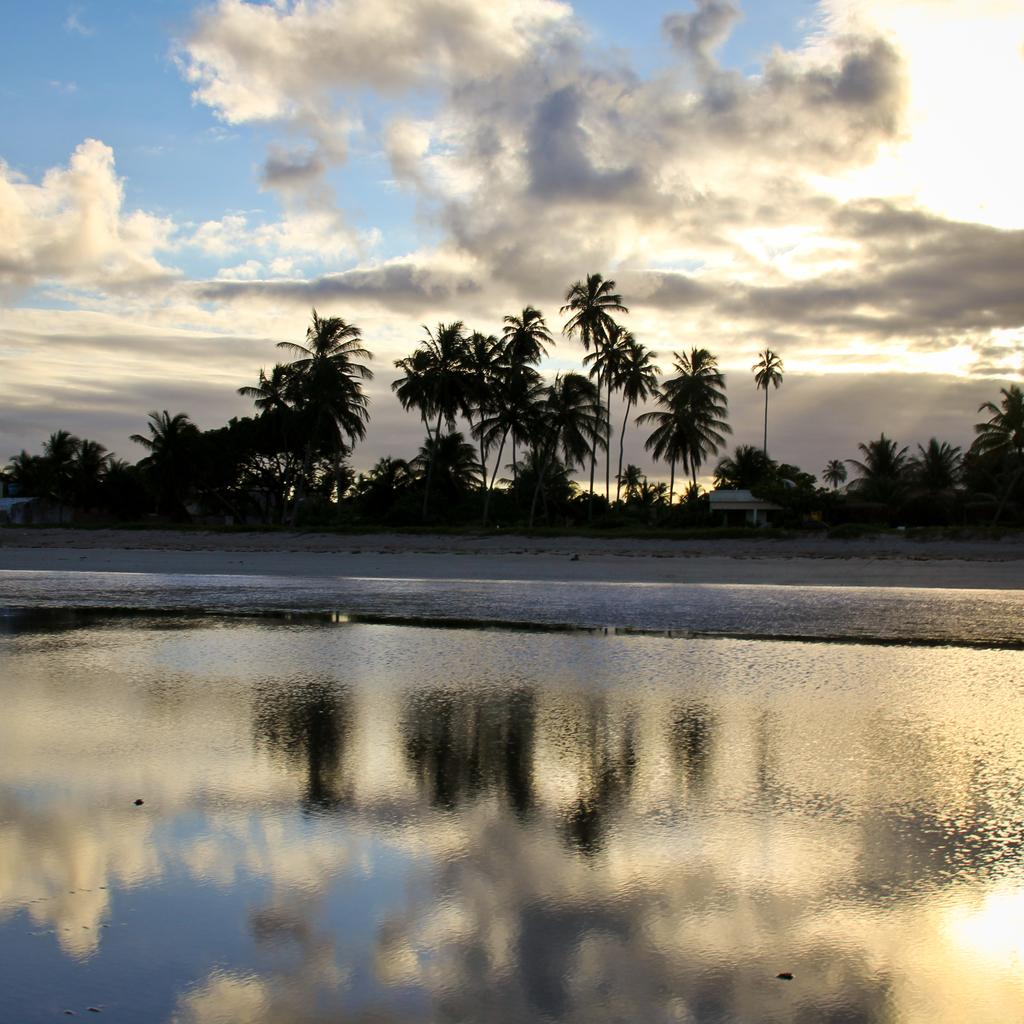What is located in the foreground of the image? There is a water body in the foreground of the image. What can be seen in the background of the image? There are trees and buildings in the background of the image. What is the condition of the sky in the image? The sky is cloudy in the image. What type of jam is being spread on the engine in the image? There is no jam or engine present in the image. How does the plough affect the trees in the background of the image? There is no plough present in the image, so it cannot affect the trees. 